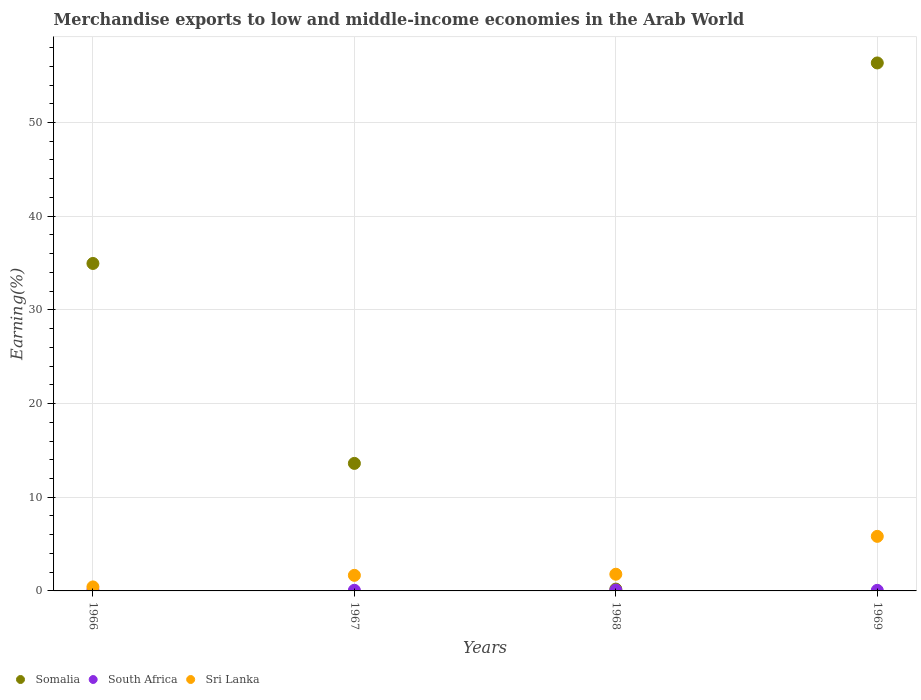How many different coloured dotlines are there?
Your response must be concise. 3. Is the number of dotlines equal to the number of legend labels?
Make the answer very short. Yes. What is the percentage of amount earned from merchandise exports in South Africa in 1967?
Your answer should be very brief. 0.07. Across all years, what is the maximum percentage of amount earned from merchandise exports in South Africa?
Your answer should be very brief. 0.09. Across all years, what is the minimum percentage of amount earned from merchandise exports in Sri Lanka?
Ensure brevity in your answer.  0.43. In which year was the percentage of amount earned from merchandise exports in Somalia maximum?
Provide a short and direct response. 1969. In which year was the percentage of amount earned from merchandise exports in Somalia minimum?
Your answer should be compact. 1968. What is the total percentage of amount earned from merchandise exports in South Africa in the graph?
Provide a succinct answer. 0.3. What is the difference between the percentage of amount earned from merchandise exports in Sri Lanka in 1966 and that in 1969?
Give a very brief answer. -5.4. What is the difference between the percentage of amount earned from merchandise exports in Somalia in 1969 and the percentage of amount earned from merchandise exports in Sri Lanka in 1967?
Keep it short and to the point. 54.7. What is the average percentage of amount earned from merchandise exports in South Africa per year?
Provide a short and direct response. 0.08. In the year 1966, what is the difference between the percentage of amount earned from merchandise exports in Sri Lanka and percentage of amount earned from merchandise exports in Somalia?
Your response must be concise. -34.53. In how many years, is the percentage of amount earned from merchandise exports in Somalia greater than 6 %?
Your response must be concise. 3. What is the ratio of the percentage of amount earned from merchandise exports in Somalia in 1966 to that in 1969?
Offer a terse response. 0.62. Is the percentage of amount earned from merchandise exports in Somalia in 1968 less than that in 1969?
Your response must be concise. Yes. Is the difference between the percentage of amount earned from merchandise exports in Sri Lanka in 1967 and 1968 greater than the difference between the percentage of amount earned from merchandise exports in Somalia in 1967 and 1968?
Provide a succinct answer. No. What is the difference between the highest and the second highest percentage of amount earned from merchandise exports in Somalia?
Offer a terse response. 21.4. What is the difference between the highest and the lowest percentage of amount earned from merchandise exports in Somalia?
Provide a short and direct response. 56.16. How many dotlines are there?
Offer a very short reply. 3. How many years are there in the graph?
Provide a short and direct response. 4. Are the values on the major ticks of Y-axis written in scientific E-notation?
Your response must be concise. No. Does the graph contain any zero values?
Give a very brief answer. No. Where does the legend appear in the graph?
Offer a terse response. Bottom left. How many legend labels are there?
Your answer should be very brief. 3. What is the title of the graph?
Make the answer very short. Merchandise exports to low and middle-income economies in the Arab World. What is the label or title of the X-axis?
Keep it short and to the point. Years. What is the label or title of the Y-axis?
Ensure brevity in your answer.  Earning(%). What is the Earning(%) in Somalia in 1966?
Offer a terse response. 34.95. What is the Earning(%) in South Africa in 1966?
Provide a short and direct response. 0.08. What is the Earning(%) of Sri Lanka in 1966?
Keep it short and to the point. 0.43. What is the Earning(%) of Somalia in 1967?
Your response must be concise. 13.61. What is the Earning(%) in South Africa in 1967?
Ensure brevity in your answer.  0.07. What is the Earning(%) in Sri Lanka in 1967?
Keep it short and to the point. 1.66. What is the Earning(%) in Somalia in 1968?
Offer a terse response. 0.2. What is the Earning(%) in South Africa in 1968?
Keep it short and to the point. 0.09. What is the Earning(%) in Sri Lanka in 1968?
Keep it short and to the point. 1.78. What is the Earning(%) in Somalia in 1969?
Offer a terse response. 56.36. What is the Earning(%) in South Africa in 1969?
Keep it short and to the point. 0.06. What is the Earning(%) in Sri Lanka in 1969?
Keep it short and to the point. 5.82. Across all years, what is the maximum Earning(%) in Somalia?
Keep it short and to the point. 56.36. Across all years, what is the maximum Earning(%) of South Africa?
Ensure brevity in your answer.  0.09. Across all years, what is the maximum Earning(%) of Sri Lanka?
Make the answer very short. 5.82. Across all years, what is the minimum Earning(%) of Somalia?
Your response must be concise. 0.2. Across all years, what is the minimum Earning(%) in South Africa?
Offer a terse response. 0.06. Across all years, what is the minimum Earning(%) of Sri Lanka?
Provide a short and direct response. 0.43. What is the total Earning(%) of Somalia in the graph?
Provide a short and direct response. 105.12. What is the total Earning(%) in South Africa in the graph?
Your response must be concise. 0.3. What is the total Earning(%) in Sri Lanka in the graph?
Offer a terse response. 9.69. What is the difference between the Earning(%) of Somalia in 1966 and that in 1967?
Provide a short and direct response. 21.34. What is the difference between the Earning(%) of South Africa in 1966 and that in 1967?
Give a very brief answer. 0.01. What is the difference between the Earning(%) of Sri Lanka in 1966 and that in 1967?
Keep it short and to the point. -1.24. What is the difference between the Earning(%) in Somalia in 1966 and that in 1968?
Provide a succinct answer. 34.76. What is the difference between the Earning(%) in South Africa in 1966 and that in 1968?
Offer a terse response. -0.01. What is the difference between the Earning(%) in Sri Lanka in 1966 and that in 1968?
Make the answer very short. -1.35. What is the difference between the Earning(%) of Somalia in 1966 and that in 1969?
Offer a terse response. -21.4. What is the difference between the Earning(%) of South Africa in 1966 and that in 1969?
Your response must be concise. 0.02. What is the difference between the Earning(%) in Sri Lanka in 1966 and that in 1969?
Offer a terse response. -5.4. What is the difference between the Earning(%) in Somalia in 1967 and that in 1968?
Your answer should be very brief. 13.42. What is the difference between the Earning(%) of South Africa in 1967 and that in 1968?
Ensure brevity in your answer.  -0.03. What is the difference between the Earning(%) of Sri Lanka in 1967 and that in 1968?
Provide a short and direct response. -0.12. What is the difference between the Earning(%) of Somalia in 1967 and that in 1969?
Give a very brief answer. -42.75. What is the difference between the Earning(%) of South Africa in 1967 and that in 1969?
Your answer should be very brief. 0.01. What is the difference between the Earning(%) of Sri Lanka in 1967 and that in 1969?
Offer a very short reply. -4.16. What is the difference between the Earning(%) of Somalia in 1968 and that in 1969?
Provide a short and direct response. -56.16. What is the difference between the Earning(%) in South Africa in 1968 and that in 1969?
Your response must be concise. 0.03. What is the difference between the Earning(%) in Sri Lanka in 1968 and that in 1969?
Provide a succinct answer. -4.04. What is the difference between the Earning(%) in Somalia in 1966 and the Earning(%) in South Africa in 1967?
Provide a short and direct response. 34.89. What is the difference between the Earning(%) of Somalia in 1966 and the Earning(%) of Sri Lanka in 1967?
Give a very brief answer. 33.29. What is the difference between the Earning(%) of South Africa in 1966 and the Earning(%) of Sri Lanka in 1967?
Your response must be concise. -1.58. What is the difference between the Earning(%) of Somalia in 1966 and the Earning(%) of South Africa in 1968?
Your answer should be compact. 34.86. What is the difference between the Earning(%) of Somalia in 1966 and the Earning(%) of Sri Lanka in 1968?
Your answer should be compact. 33.17. What is the difference between the Earning(%) of South Africa in 1966 and the Earning(%) of Sri Lanka in 1968?
Give a very brief answer. -1.7. What is the difference between the Earning(%) in Somalia in 1966 and the Earning(%) in South Africa in 1969?
Give a very brief answer. 34.89. What is the difference between the Earning(%) of Somalia in 1966 and the Earning(%) of Sri Lanka in 1969?
Your answer should be compact. 29.13. What is the difference between the Earning(%) in South Africa in 1966 and the Earning(%) in Sri Lanka in 1969?
Make the answer very short. -5.74. What is the difference between the Earning(%) in Somalia in 1967 and the Earning(%) in South Africa in 1968?
Offer a terse response. 13.52. What is the difference between the Earning(%) of Somalia in 1967 and the Earning(%) of Sri Lanka in 1968?
Provide a short and direct response. 11.83. What is the difference between the Earning(%) in South Africa in 1967 and the Earning(%) in Sri Lanka in 1968?
Provide a succinct answer. -1.71. What is the difference between the Earning(%) of Somalia in 1967 and the Earning(%) of South Africa in 1969?
Offer a terse response. 13.55. What is the difference between the Earning(%) of Somalia in 1967 and the Earning(%) of Sri Lanka in 1969?
Your response must be concise. 7.79. What is the difference between the Earning(%) of South Africa in 1967 and the Earning(%) of Sri Lanka in 1969?
Provide a short and direct response. -5.76. What is the difference between the Earning(%) of Somalia in 1968 and the Earning(%) of South Africa in 1969?
Offer a very short reply. 0.13. What is the difference between the Earning(%) in Somalia in 1968 and the Earning(%) in Sri Lanka in 1969?
Keep it short and to the point. -5.63. What is the difference between the Earning(%) of South Africa in 1968 and the Earning(%) of Sri Lanka in 1969?
Give a very brief answer. -5.73. What is the average Earning(%) in Somalia per year?
Offer a terse response. 26.28. What is the average Earning(%) of South Africa per year?
Offer a terse response. 0.08. What is the average Earning(%) in Sri Lanka per year?
Your response must be concise. 2.42. In the year 1966, what is the difference between the Earning(%) in Somalia and Earning(%) in South Africa?
Keep it short and to the point. 34.87. In the year 1966, what is the difference between the Earning(%) of Somalia and Earning(%) of Sri Lanka?
Offer a terse response. 34.53. In the year 1966, what is the difference between the Earning(%) of South Africa and Earning(%) of Sri Lanka?
Make the answer very short. -0.35. In the year 1967, what is the difference between the Earning(%) of Somalia and Earning(%) of South Africa?
Make the answer very short. 13.55. In the year 1967, what is the difference between the Earning(%) in Somalia and Earning(%) in Sri Lanka?
Your answer should be compact. 11.95. In the year 1967, what is the difference between the Earning(%) of South Africa and Earning(%) of Sri Lanka?
Your answer should be compact. -1.6. In the year 1968, what is the difference between the Earning(%) of Somalia and Earning(%) of South Africa?
Offer a terse response. 0.1. In the year 1968, what is the difference between the Earning(%) of Somalia and Earning(%) of Sri Lanka?
Provide a succinct answer. -1.59. In the year 1968, what is the difference between the Earning(%) of South Africa and Earning(%) of Sri Lanka?
Ensure brevity in your answer.  -1.69. In the year 1969, what is the difference between the Earning(%) in Somalia and Earning(%) in South Africa?
Your response must be concise. 56.3. In the year 1969, what is the difference between the Earning(%) in Somalia and Earning(%) in Sri Lanka?
Offer a very short reply. 50.53. In the year 1969, what is the difference between the Earning(%) in South Africa and Earning(%) in Sri Lanka?
Ensure brevity in your answer.  -5.76. What is the ratio of the Earning(%) in Somalia in 1966 to that in 1967?
Give a very brief answer. 2.57. What is the ratio of the Earning(%) of South Africa in 1966 to that in 1967?
Your answer should be compact. 1.21. What is the ratio of the Earning(%) in Sri Lanka in 1966 to that in 1967?
Your answer should be very brief. 0.26. What is the ratio of the Earning(%) of Somalia in 1966 to that in 1968?
Your answer should be compact. 178.87. What is the ratio of the Earning(%) of South Africa in 1966 to that in 1968?
Your answer should be compact. 0.87. What is the ratio of the Earning(%) in Sri Lanka in 1966 to that in 1968?
Provide a short and direct response. 0.24. What is the ratio of the Earning(%) in Somalia in 1966 to that in 1969?
Provide a short and direct response. 0.62. What is the ratio of the Earning(%) of South Africa in 1966 to that in 1969?
Your answer should be compact. 1.3. What is the ratio of the Earning(%) in Sri Lanka in 1966 to that in 1969?
Offer a terse response. 0.07. What is the ratio of the Earning(%) of Somalia in 1967 to that in 1968?
Ensure brevity in your answer.  69.66. What is the ratio of the Earning(%) in South Africa in 1967 to that in 1968?
Your answer should be very brief. 0.72. What is the ratio of the Earning(%) of Sri Lanka in 1967 to that in 1968?
Keep it short and to the point. 0.93. What is the ratio of the Earning(%) of Somalia in 1967 to that in 1969?
Provide a succinct answer. 0.24. What is the ratio of the Earning(%) in South Africa in 1967 to that in 1969?
Give a very brief answer. 1.08. What is the ratio of the Earning(%) of Sri Lanka in 1967 to that in 1969?
Your answer should be very brief. 0.29. What is the ratio of the Earning(%) in Somalia in 1968 to that in 1969?
Your answer should be very brief. 0. What is the ratio of the Earning(%) of South Africa in 1968 to that in 1969?
Your response must be concise. 1.49. What is the ratio of the Earning(%) of Sri Lanka in 1968 to that in 1969?
Give a very brief answer. 0.31. What is the difference between the highest and the second highest Earning(%) in Somalia?
Provide a succinct answer. 21.4. What is the difference between the highest and the second highest Earning(%) of South Africa?
Your response must be concise. 0.01. What is the difference between the highest and the second highest Earning(%) of Sri Lanka?
Provide a succinct answer. 4.04. What is the difference between the highest and the lowest Earning(%) of Somalia?
Your response must be concise. 56.16. What is the difference between the highest and the lowest Earning(%) in South Africa?
Your answer should be compact. 0.03. What is the difference between the highest and the lowest Earning(%) of Sri Lanka?
Your answer should be compact. 5.4. 